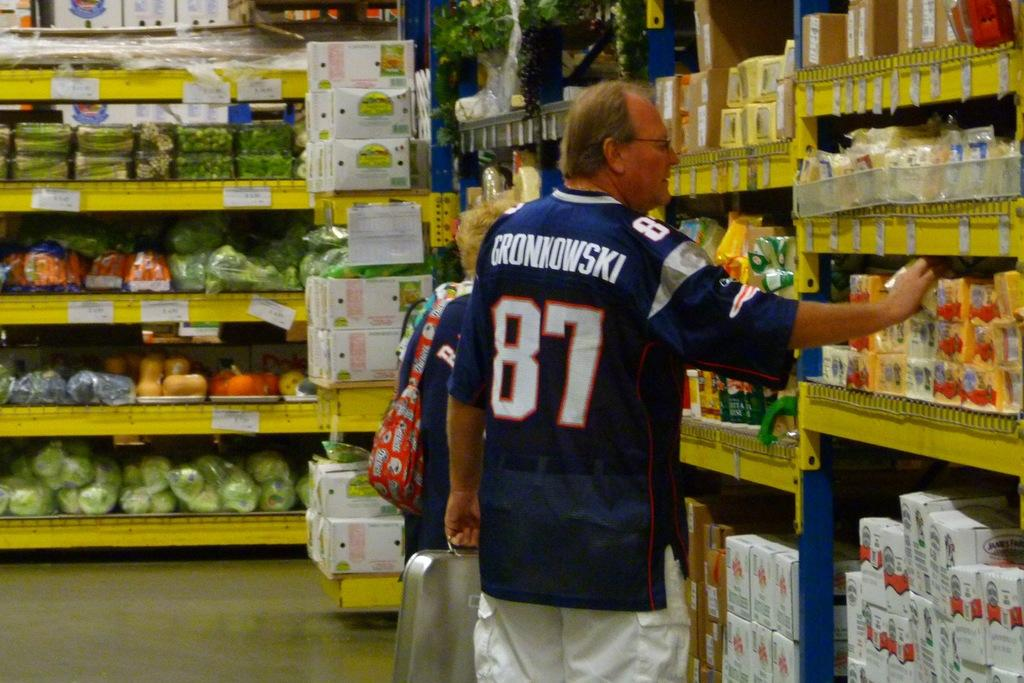<image>
Present a compact description of the photo's key features. A man in the supermarket wearing a Grownwokski football jersey. 